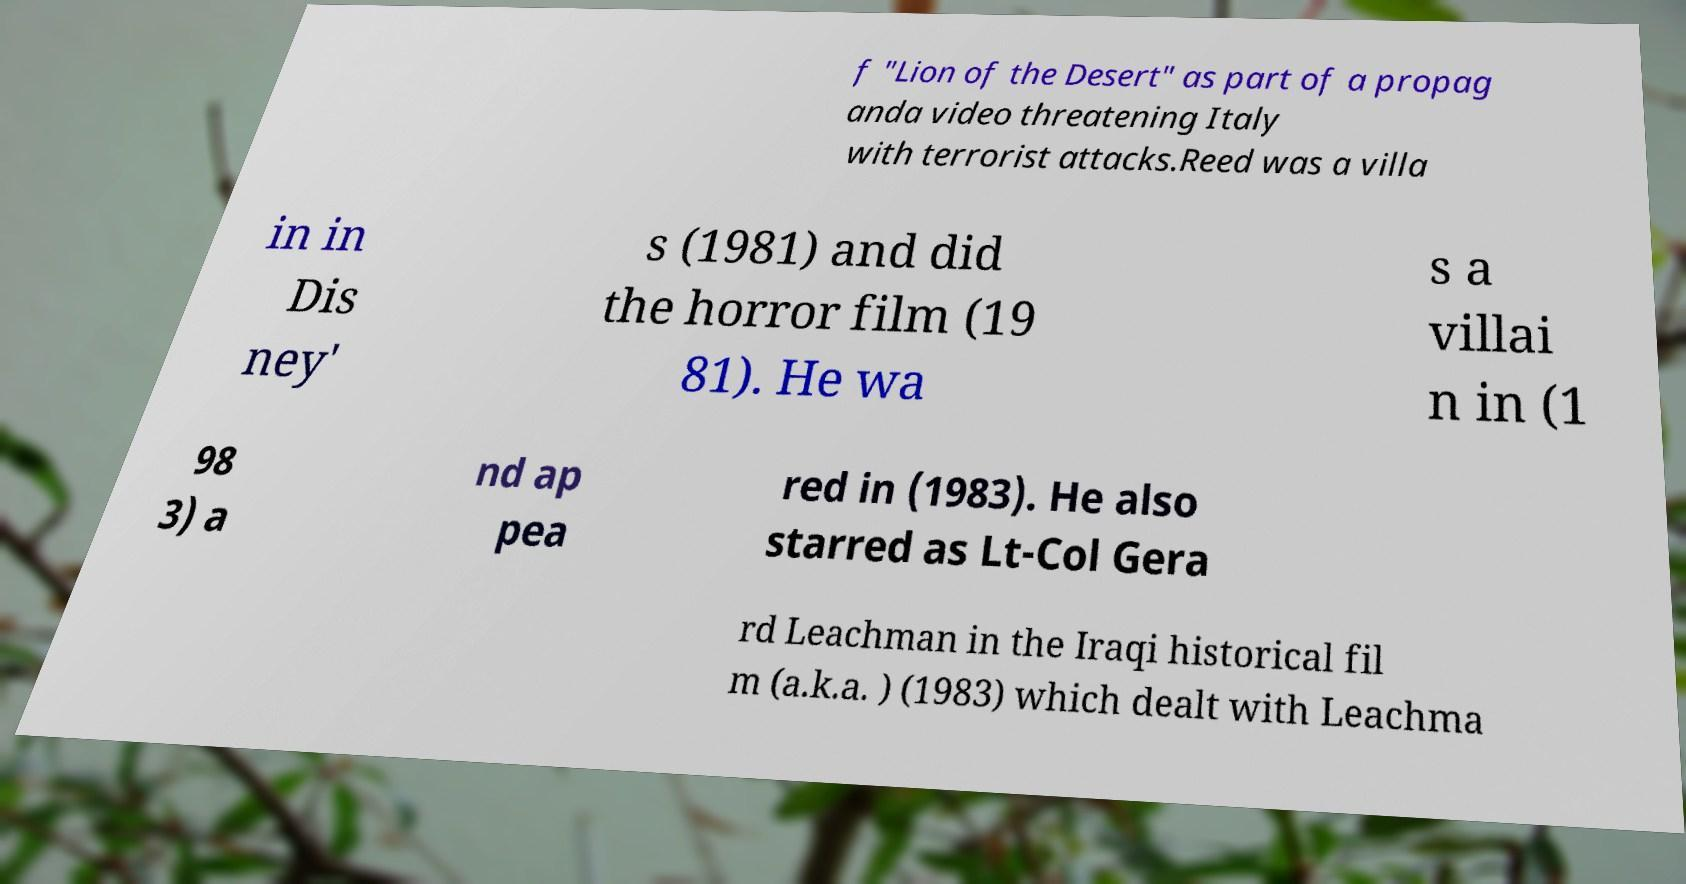Please read and relay the text visible in this image. What does it say? f "Lion of the Desert" as part of a propag anda video threatening Italy with terrorist attacks.Reed was a villa in in Dis ney' s (1981) and did the horror film (19 81). He wa s a villai n in (1 98 3) a nd ap pea red in (1983). He also starred as Lt-Col Gera rd Leachman in the Iraqi historical fil m (a.k.a. ) (1983) which dealt with Leachma 